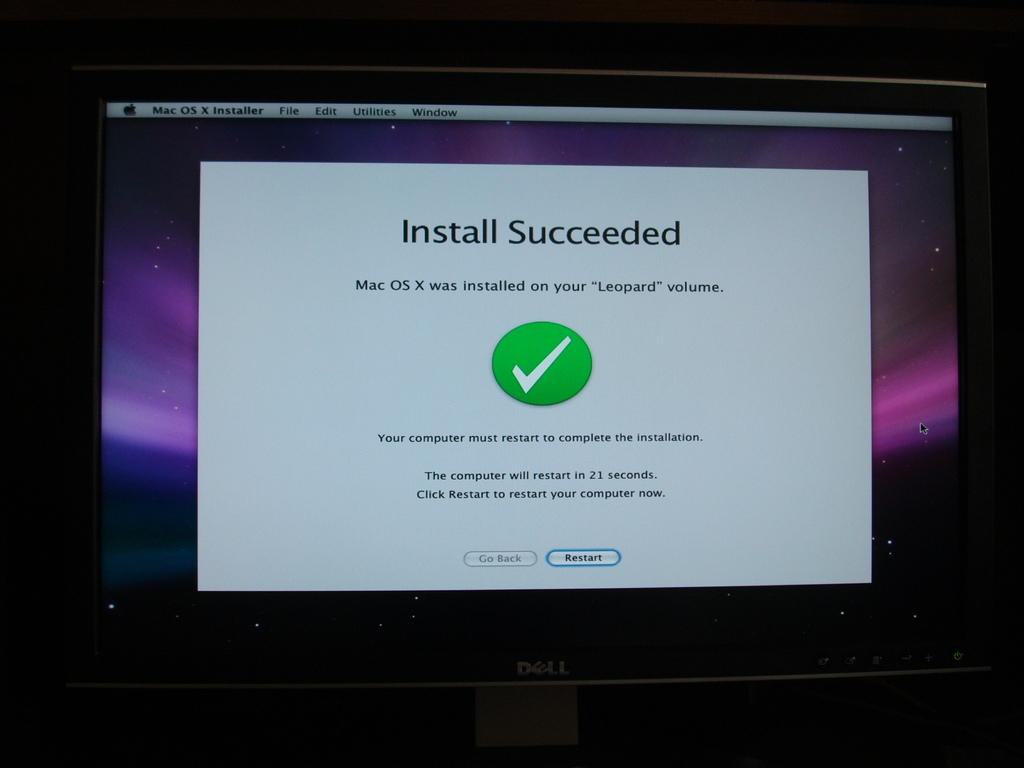<image>
Offer a succinct explanation of the picture presented. The Dell computer has a notification on the screen that the Mac operating system was successfully installed on the computer. 